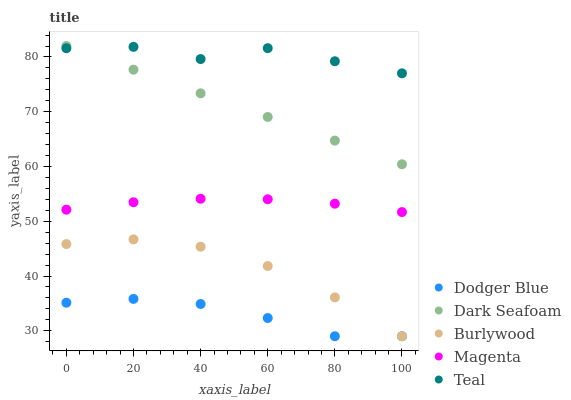Does Dodger Blue have the minimum area under the curve?
Answer yes or no. Yes. Does Teal have the maximum area under the curve?
Answer yes or no. Yes. Does Dark Seafoam have the minimum area under the curve?
Answer yes or no. No. Does Dark Seafoam have the maximum area under the curve?
Answer yes or no. No. Is Dark Seafoam the smoothest?
Answer yes or no. Yes. Is Teal the roughest?
Answer yes or no. Yes. Is Dodger Blue the smoothest?
Answer yes or no. No. Is Dodger Blue the roughest?
Answer yes or no. No. Does Burlywood have the lowest value?
Answer yes or no. Yes. Does Dark Seafoam have the lowest value?
Answer yes or no. No. Does Dark Seafoam have the highest value?
Answer yes or no. Yes. Does Dodger Blue have the highest value?
Answer yes or no. No. Is Dodger Blue less than Dark Seafoam?
Answer yes or no. Yes. Is Dark Seafoam greater than Magenta?
Answer yes or no. Yes. Does Dodger Blue intersect Burlywood?
Answer yes or no. Yes. Is Dodger Blue less than Burlywood?
Answer yes or no. No. Is Dodger Blue greater than Burlywood?
Answer yes or no. No. Does Dodger Blue intersect Dark Seafoam?
Answer yes or no. No. 